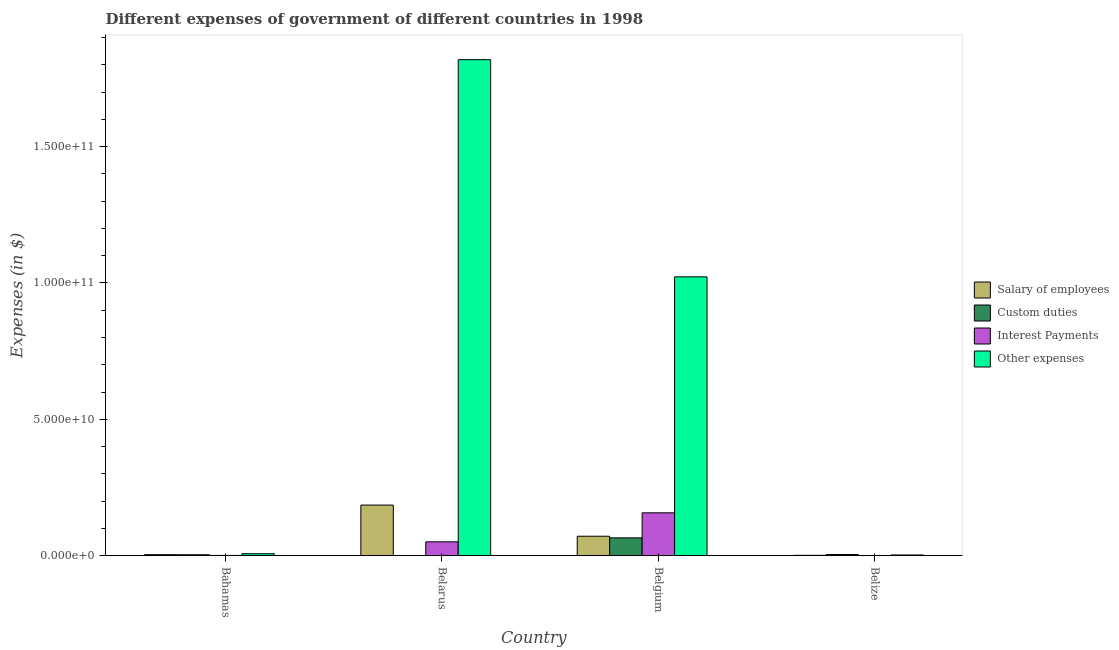How many different coloured bars are there?
Provide a succinct answer. 4. How many groups of bars are there?
Your answer should be compact. 4. What is the label of the 3rd group of bars from the left?
Your answer should be compact. Belgium. What is the amount spent on other expenses in Belarus?
Your answer should be very brief. 1.82e+11. Across all countries, what is the maximum amount spent on other expenses?
Provide a succinct answer. 1.82e+11. Across all countries, what is the minimum amount spent on other expenses?
Provide a short and direct response. 2.73e+08. In which country was the amount spent on salary of employees minimum?
Your answer should be compact. Belize. What is the total amount spent on interest payments in the graph?
Give a very brief answer. 2.09e+1. What is the difference between the amount spent on custom duties in Bahamas and that in Belarus?
Offer a terse response. 3.18e+08. What is the difference between the amount spent on custom duties in Belgium and the amount spent on other expenses in Belize?
Your answer should be compact. 6.27e+09. What is the average amount spent on other expenses per country?
Keep it short and to the point. 7.13e+1. What is the difference between the amount spent on salary of employees and amount spent on other expenses in Belgium?
Offer a terse response. -9.51e+1. What is the ratio of the amount spent on other expenses in Bahamas to that in Belize?
Provide a short and direct response. 2.68. Is the amount spent on salary of employees in Belarus less than that in Belgium?
Ensure brevity in your answer.  No. What is the difference between the highest and the second highest amount spent on salary of employees?
Offer a very short reply. 1.14e+1. What is the difference between the highest and the lowest amount spent on other expenses?
Give a very brief answer. 1.82e+11. Is the sum of the amount spent on custom duties in Bahamas and Belgium greater than the maximum amount spent on other expenses across all countries?
Ensure brevity in your answer.  No. Is it the case that in every country, the sum of the amount spent on salary of employees and amount spent on custom duties is greater than the sum of amount spent on interest payments and amount spent on other expenses?
Give a very brief answer. No. What does the 3rd bar from the left in Belarus represents?
Ensure brevity in your answer.  Interest Payments. What does the 2nd bar from the right in Belize represents?
Keep it short and to the point. Interest Payments. How many countries are there in the graph?
Offer a very short reply. 4. What is the difference between two consecutive major ticks on the Y-axis?
Make the answer very short. 5.00e+1. Are the values on the major ticks of Y-axis written in scientific E-notation?
Ensure brevity in your answer.  Yes. Does the graph contain any zero values?
Your answer should be compact. No. How are the legend labels stacked?
Provide a succinct answer. Vertical. What is the title of the graph?
Provide a short and direct response. Different expenses of government of different countries in 1998. What is the label or title of the Y-axis?
Your answer should be compact. Expenses (in $). What is the Expenses (in $) of Salary of employees in Bahamas?
Give a very brief answer. 3.84e+08. What is the Expenses (in $) in Custom duties in Bahamas?
Provide a succinct answer. 3.47e+08. What is the Expenses (in $) in Interest Payments in Bahamas?
Ensure brevity in your answer.  9.91e+07. What is the Expenses (in $) of Other expenses in Bahamas?
Provide a succinct answer. 7.32e+08. What is the Expenses (in $) of Salary of employees in Belarus?
Offer a very short reply. 1.86e+1. What is the Expenses (in $) of Custom duties in Belarus?
Offer a very short reply. 2.98e+07. What is the Expenses (in $) in Interest Payments in Belarus?
Ensure brevity in your answer.  5.09e+09. What is the Expenses (in $) of Other expenses in Belarus?
Offer a terse response. 1.82e+11. What is the Expenses (in $) in Salary of employees in Belgium?
Your answer should be compact. 7.14e+09. What is the Expenses (in $) in Custom duties in Belgium?
Your response must be concise. 6.54e+09. What is the Expenses (in $) of Interest Payments in Belgium?
Offer a very short reply. 1.57e+1. What is the Expenses (in $) in Other expenses in Belgium?
Your answer should be very brief. 1.02e+11. What is the Expenses (in $) in Salary of employees in Belize?
Give a very brief answer. 1.40e+08. What is the Expenses (in $) of Custom duties in Belize?
Provide a succinct answer. 4.40e+08. What is the Expenses (in $) in Interest Payments in Belize?
Offer a very short reply. 2.46e+07. What is the Expenses (in $) in Other expenses in Belize?
Provide a short and direct response. 2.73e+08. Across all countries, what is the maximum Expenses (in $) of Salary of employees?
Offer a terse response. 1.86e+1. Across all countries, what is the maximum Expenses (in $) in Custom duties?
Ensure brevity in your answer.  6.54e+09. Across all countries, what is the maximum Expenses (in $) of Interest Payments?
Offer a very short reply. 1.57e+1. Across all countries, what is the maximum Expenses (in $) in Other expenses?
Give a very brief answer. 1.82e+11. Across all countries, what is the minimum Expenses (in $) of Salary of employees?
Provide a succinct answer. 1.40e+08. Across all countries, what is the minimum Expenses (in $) in Custom duties?
Provide a succinct answer. 2.98e+07. Across all countries, what is the minimum Expenses (in $) of Interest Payments?
Offer a very short reply. 2.46e+07. Across all countries, what is the minimum Expenses (in $) of Other expenses?
Provide a short and direct response. 2.73e+08. What is the total Expenses (in $) of Salary of employees in the graph?
Offer a terse response. 2.62e+1. What is the total Expenses (in $) of Custom duties in the graph?
Your answer should be compact. 7.36e+09. What is the total Expenses (in $) in Interest Payments in the graph?
Your answer should be very brief. 2.09e+1. What is the total Expenses (in $) in Other expenses in the graph?
Offer a terse response. 2.85e+11. What is the difference between the Expenses (in $) in Salary of employees in Bahamas and that in Belarus?
Make the answer very short. -1.82e+1. What is the difference between the Expenses (in $) in Custom duties in Bahamas and that in Belarus?
Keep it short and to the point. 3.18e+08. What is the difference between the Expenses (in $) of Interest Payments in Bahamas and that in Belarus?
Offer a terse response. -4.99e+09. What is the difference between the Expenses (in $) of Other expenses in Bahamas and that in Belarus?
Give a very brief answer. -1.81e+11. What is the difference between the Expenses (in $) of Salary of employees in Bahamas and that in Belgium?
Offer a very short reply. -6.76e+09. What is the difference between the Expenses (in $) in Custom duties in Bahamas and that in Belgium?
Keep it short and to the point. -6.20e+09. What is the difference between the Expenses (in $) in Interest Payments in Bahamas and that in Belgium?
Provide a short and direct response. -1.56e+1. What is the difference between the Expenses (in $) of Other expenses in Bahamas and that in Belgium?
Keep it short and to the point. -1.02e+11. What is the difference between the Expenses (in $) in Salary of employees in Bahamas and that in Belize?
Your answer should be very brief. 2.44e+08. What is the difference between the Expenses (in $) of Custom duties in Bahamas and that in Belize?
Provide a short and direct response. -9.30e+07. What is the difference between the Expenses (in $) of Interest Payments in Bahamas and that in Belize?
Provide a succinct answer. 7.45e+07. What is the difference between the Expenses (in $) of Other expenses in Bahamas and that in Belize?
Give a very brief answer. 4.59e+08. What is the difference between the Expenses (in $) of Salary of employees in Belarus and that in Belgium?
Your response must be concise. 1.14e+1. What is the difference between the Expenses (in $) of Custom duties in Belarus and that in Belgium?
Offer a terse response. -6.51e+09. What is the difference between the Expenses (in $) of Interest Payments in Belarus and that in Belgium?
Keep it short and to the point. -1.06e+1. What is the difference between the Expenses (in $) in Other expenses in Belarus and that in Belgium?
Provide a succinct answer. 7.96e+1. What is the difference between the Expenses (in $) in Salary of employees in Belarus and that in Belize?
Provide a short and direct response. 1.84e+1. What is the difference between the Expenses (in $) in Custom duties in Belarus and that in Belize?
Offer a terse response. -4.11e+08. What is the difference between the Expenses (in $) of Interest Payments in Belarus and that in Belize?
Keep it short and to the point. 5.06e+09. What is the difference between the Expenses (in $) in Other expenses in Belarus and that in Belize?
Give a very brief answer. 1.82e+11. What is the difference between the Expenses (in $) in Salary of employees in Belgium and that in Belize?
Give a very brief answer. 7.00e+09. What is the difference between the Expenses (in $) of Custom duties in Belgium and that in Belize?
Provide a short and direct response. 6.10e+09. What is the difference between the Expenses (in $) of Interest Payments in Belgium and that in Belize?
Offer a terse response. 1.57e+1. What is the difference between the Expenses (in $) of Other expenses in Belgium and that in Belize?
Your answer should be compact. 1.02e+11. What is the difference between the Expenses (in $) in Salary of employees in Bahamas and the Expenses (in $) in Custom duties in Belarus?
Your response must be concise. 3.54e+08. What is the difference between the Expenses (in $) of Salary of employees in Bahamas and the Expenses (in $) of Interest Payments in Belarus?
Make the answer very short. -4.70e+09. What is the difference between the Expenses (in $) of Salary of employees in Bahamas and the Expenses (in $) of Other expenses in Belarus?
Ensure brevity in your answer.  -1.82e+11. What is the difference between the Expenses (in $) of Custom duties in Bahamas and the Expenses (in $) of Interest Payments in Belarus?
Your answer should be compact. -4.74e+09. What is the difference between the Expenses (in $) of Custom duties in Bahamas and the Expenses (in $) of Other expenses in Belarus?
Keep it short and to the point. -1.82e+11. What is the difference between the Expenses (in $) in Interest Payments in Bahamas and the Expenses (in $) in Other expenses in Belarus?
Provide a short and direct response. -1.82e+11. What is the difference between the Expenses (in $) of Salary of employees in Bahamas and the Expenses (in $) of Custom duties in Belgium?
Your response must be concise. -6.16e+09. What is the difference between the Expenses (in $) in Salary of employees in Bahamas and the Expenses (in $) in Interest Payments in Belgium?
Give a very brief answer. -1.53e+1. What is the difference between the Expenses (in $) in Salary of employees in Bahamas and the Expenses (in $) in Other expenses in Belgium?
Provide a succinct answer. -1.02e+11. What is the difference between the Expenses (in $) in Custom duties in Bahamas and the Expenses (in $) in Interest Payments in Belgium?
Keep it short and to the point. -1.54e+1. What is the difference between the Expenses (in $) in Custom duties in Bahamas and the Expenses (in $) in Other expenses in Belgium?
Keep it short and to the point. -1.02e+11. What is the difference between the Expenses (in $) in Interest Payments in Bahamas and the Expenses (in $) in Other expenses in Belgium?
Your response must be concise. -1.02e+11. What is the difference between the Expenses (in $) in Salary of employees in Bahamas and the Expenses (in $) in Custom duties in Belize?
Your response must be concise. -5.65e+07. What is the difference between the Expenses (in $) of Salary of employees in Bahamas and the Expenses (in $) of Interest Payments in Belize?
Give a very brief answer. 3.59e+08. What is the difference between the Expenses (in $) in Salary of employees in Bahamas and the Expenses (in $) in Other expenses in Belize?
Keep it short and to the point. 1.11e+08. What is the difference between the Expenses (in $) of Custom duties in Bahamas and the Expenses (in $) of Interest Payments in Belize?
Provide a succinct answer. 3.23e+08. What is the difference between the Expenses (in $) of Custom duties in Bahamas and the Expenses (in $) of Other expenses in Belize?
Ensure brevity in your answer.  7.44e+07. What is the difference between the Expenses (in $) of Interest Payments in Bahamas and the Expenses (in $) of Other expenses in Belize?
Make the answer very short. -1.74e+08. What is the difference between the Expenses (in $) of Salary of employees in Belarus and the Expenses (in $) of Custom duties in Belgium?
Keep it short and to the point. 1.20e+1. What is the difference between the Expenses (in $) of Salary of employees in Belarus and the Expenses (in $) of Interest Payments in Belgium?
Give a very brief answer. 2.84e+09. What is the difference between the Expenses (in $) in Salary of employees in Belarus and the Expenses (in $) in Other expenses in Belgium?
Your response must be concise. -8.37e+1. What is the difference between the Expenses (in $) in Custom duties in Belarus and the Expenses (in $) in Interest Payments in Belgium?
Ensure brevity in your answer.  -1.57e+1. What is the difference between the Expenses (in $) of Custom duties in Belarus and the Expenses (in $) of Other expenses in Belgium?
Provide a succinct answer. -1.02e+11. What is the difference between the Expenses (in $) of Interest Payments in Belarus and the Expenses (in $) of Other expenses in Belgium?
Your answer should be compact. -9.72e+1. What is the difference between the Expenses (in $) of Salary of employees in Belarus and the Expenses (in $) of Custom duties in Belize?
Your answer should be compact. 1.81e+1. What is the difference between the Expenses (in $) in Salary of employees in Belarus and the Expenses (in $) in Interest Payments in Belize?
Provide a succinct answer. 1.85e+1. What is the difference between the Expenses (in $) in Salary of employees in Belarus and the Expenses (in $) in Other expenses in Belize?
Your response must be concise. 1.83e+1. What is the difference between the Expenses (in $) of Custom duties in Belarus and the Expenses (in $) of Interest Payments in Belize?
Provide a succinct answer. 5.18e+06. What is the difference between the Expenses (in $) of Custom duties in Belarus and the Expenses (in $) of Other expenses in Belize?
Give a very brief answer. -2.43e+08. What is the difference between the Expenses (in $) of Interest Payments in Belarus and the Expenses (in $) of Other expenses in Belize?
Your answer should be compact. 4.81e+09. What is the difference between the Expenses (in $) of Salary of employees in Belgium and the Expenses (in $) of Custom duties in Belize?
Your answer should be compact. 6.70e+09. What is the difference between the Expenses (in $) of Salary of employees in Belgium and the Expenses (in $) of Interest Payments in Belize?
Offer a terse response. 7.12e+09. What is the difference between the Expenses (in $) in Salary of employees in Belgium and the Expenses (in $) in Other expenses in Belize?
Offer a terse response. 6.87e+09. What is the difference between the Expenses (in $) of Custom duties in Belgium and the Expenses (in $) of Interest Payments in Belize?
Offer a terse response. 6.52e+09. What is the difference between the Expenses (in $) of Custom duties in Belgium and the Expenses (in $) of Other expenses in Belize?
Your answer should be very brief. 6.27e+09. What is the difference between the Expenses (in $) of Interest Payments in Belgium and the Expenses (in $) of Other expenses in Belize?
Ensure brevity in your answer.  1.55e+1. What is the average Expenses (in $) in Salary of employees per country?
Give a very brief answer. 6.56e+09. What is the average Expenses (in $) in Custom duties per country?
Offer a very short reply. 1.84e+09. What is the average Expenses (in $) of Interest Payments per country?
Provide a succinct answer. 5.23e+09. What is the average Expenses (in $) of Other expenses per country?
Make the answer very short. 7.13e+1. What is the difference between the Expenses (in $) of Salary of employees and Expenses (in $) of Custom duties in Bahamas?
Ensure brevity in your answer.  3.65e+07. What is the difference between the Expenses (in $) of Salary of employees and Expenses (in $) of Interest Payments in Bahamas?
Ensure brevity in your answer.  2.85e+08. What is the difference between the Expenses (in $) in Salary of employees and Expenses (in $) in Other expenses in Bahamas?
Provide a short and direct response. -3.48e+08. What is the difference between the Expenses (in $) in Custom duties and Expenses (in $) in Interest Payments in Bahamas?
Ensure brevity in your answer.  2.48e+08. What is the difference between the Expenses (in $) of Custom duties and Expenses (in $) of Other expenses in Bahamas?
Offer a terse response. -3.84e+08. What is the difference between the Expenses (in $) of Interest Payments and Expenses (in $) of Other expenses in Bahamas?
Keep it short and to the point. -6.33e+08. What is the difference between the Expenses (in $) of Salary of employees and Expenses (in $) of Custom duties in Belarus?
Make the answer very short. 1.85e+1. What is the difference between the Expenses (in $) of Salary of employees and Expenses (in $) of Interest Payments in Belarus?
Provide a short and direct response. 1.35e+1. What is the difference between the Expenses (in $) in Salary of employees and Expenses (in $) in Other expenses in Belarus?
Your answer should be compact. -1.63e+11. What is the difference between the Expenses (in $) of Custom duties and Expenses (in $) of Interest Payments in Belarus?
Your answer should be compact. -5.06e+09. What is the difference between the Expenses (in $) of Custom duties and Expenses (in $) of Other expenses in Belarus?
Offer a very short reply. -1.82e+11. What is the difference between the Expenses (in $) in Interest Payments and Expenses (in $) in Other expenses in Belarus?
Give a very brief answer. -1.77e+11. What is the difference between the Expenses (in $) of Salary of employees and Expenses (in $) of Custom duties in Belgium?
Your response must be concise. 5.98e+08. What is the difference between the Expenses (in $) in Salary of employees and Expenses (in $) in Interest Payments in Belgium?
Provide a succinct answer. -8.58e+09. What is the difference between the Expenses (in $) of Salary of employees and Expenses (in $) of Other expenses in Belgium?
Give a very brief answer. -9.51e+1. What is the difference between the Expenses (in $) in Custom duties and Expenses (in $) in Interest Payments in Belgium?
Provide a succinct answer. -9.18e+09. What is the difference between the Expenses (in $) in Custom duties and Expenses (in $) in Other expenses in Belgium?
Ensure brevity in your answer.  -9.57e+1. What is the difference between the Expenses (in $) of Interest Payments and Expenses (in $) of Other expenses in Belgium?
Ensure brevity in your answer.  -8.65e+1. What is the difference between the Expenses (in $) of Salary of employees and Expenses (in $) of Custom duties in Belize?
Your response must be concise. -3.00e+08. What is the difference between the Expenses (in $) in Salary of employees and Expenses (in $) in Interest Payments in Belize?
Offer a very short reply. 1.16e+08. What is the difference between the Expenses (in $) of Salary of employees and Expenses (in $) of Other expenses in Belize?
Give a very brief answer. -1.33e+08. What is the difference between the Expenses (in $) in Custom duties and Expenses (in $) in Interest Payments in Belize?
Provide a short and direct response. 4.16e+08. What is the difference between the Expenses (in $) of Custom duties and Expenses (in $) of Other expenses in Belize?
Provide a short and direct response. 1.67e+08. What is the difference between the Expenses (in $) of Interest Payments and Expenses (in $) of Other expenses in Belize?
Offer a very short reply. -2.48e+08. What is the ratio of the Expenses (in $) in Salary of employees in Bahamas to that in Belarus?
Keep it short and to the point. 0.02. What is the ratio of the Expenses (in $) in Custom duties in Bahamas to that in Belarus?
Give a very brief answer. 11.67. What is the ratio of the Expenses (in $) of Interest Payments in Bahamas to that in Belarus?
Provide a succinct answer. 0.02. What is the ratio of the Expenses (in $) of Other expenses in Bahamas to that in Belarus?
Make the answer very short. 0. What is the ratio of the Expenses (in $) of Salary of employees in Bahamas to that in Belgium?
Your answer should be compact. 0.05. What is the ratio of the Expenses (in $) of Custom duties in Bahamas to that in Belgium?
Provide a succinct answer. 0.05. What is the ratio of the Expenses (in $) of Interest Payments in Bahamas to that in Belgium?
Provide a succinct answer. 0.01. What is the ratio of the Expenses (in $) of Other expenses in Bahamas to that in Belgium?
Provide a succinct answer. 0.01. What is the ratio of the Expenses (in $) of Salary of employees in Bahamas to that in Belize?
Offer a terse response. 2.74. What is the ratio of the Expenses (in $) in Custom duties in Bahamas to that in Belize?
Keep it short and to the point. 0.79. What is the ratio of the Expenses (in $) of Interest Payments in Bahamas to that in Belize?
Provide a succinct answer. 4.03. What is the ratio of the Expenses (in $) in Other expenses in Bahamas to that in Belize?
Your answer should be very brief. 2.68. What is the ratio of the Expenses (in $) in Salary of employees in Belarus to that in Belgium?
Ensure brevity in your answer.  2.6. What is the ratio of the Expenses (in $) in Custom duties in Belarus to that in Belgium?
Your response must be concise. 0. What is the ratio of the Expenses (in $) in Interest Payments in Belarus to that in Belgium?
Provide a short and direct response. 0.32. What is the ratio of the Expenses (in $) in Other expenses in Belarus to that in Belgium?
Give a very brief answer. 1.78. What is the ratio of the Expenses (in $) in Salary of employees in Belarus to that in Belize?
Your answer should be very brief. 132.33. What is the ratio of the Expenses (in $) in Custom duties in Belarus to that in Belize?
Give a very brief answer. 0.07. What is the ratio of the Expenses (in $) in Interest Payments in Belarus to that in Belize?
Provide a short and direct response. 206.81. What is the ratio of the Expenses (in $) of Other expenses in Belarus to that in Belize?
Your answer should be compact. 666.26. What is the ratio of the Expenses (in $) of Salary of employees in Belgium to that in Belize?
Give a very brief answer. 50.9. What is the ratio of the Expenses (in $) of Custom duties in Belgium to that in Belize?
Offer a very short reply. 14.86. What is the ratio of the Expenses (in $) of Interest Payments in Belgium to that in Belize?
Your answer should be very brief. 639.36. What is the ratio of the Expenses (in $) of Other expenses in Belgium to that in Belize?
Keep it short and to the point. 374.55. What is the difference between the highest and the second highest Expenses (in $) of Salary of employees?
Provide a succinct answer. 1.14e+1. What is the difference between the highest and the second highest Expenses (in $) in Custom duties?
Provide a succinct answer. 6.10e+09. What is the difference between the highest and the second highest Expenses (in $) of Interest Payments?
Offer a very short reply. 1.06e+1. What is the difference between the highest and the second highest Expenses (in $) in Other expenses?
Make the answer very short. 7.96e+1. What is the difference between the highest and the lowest Expenses (in $) of Salary of employees?
Give a very brief answer. 1.84e+1. What is the difference between the highest and the lowest Expenses (in $) of Custom duties?
Your answer should be compact. 6.51e+09. What is the difference between the highest and the lowest Expenses (in $) in Interest Payments?
Give a very brief answer. 1.57e+1. What is the difference between the highest and the lowest Expenses (in $) in Other expenses?
Provide a succinct answer. 1.82e+11. 